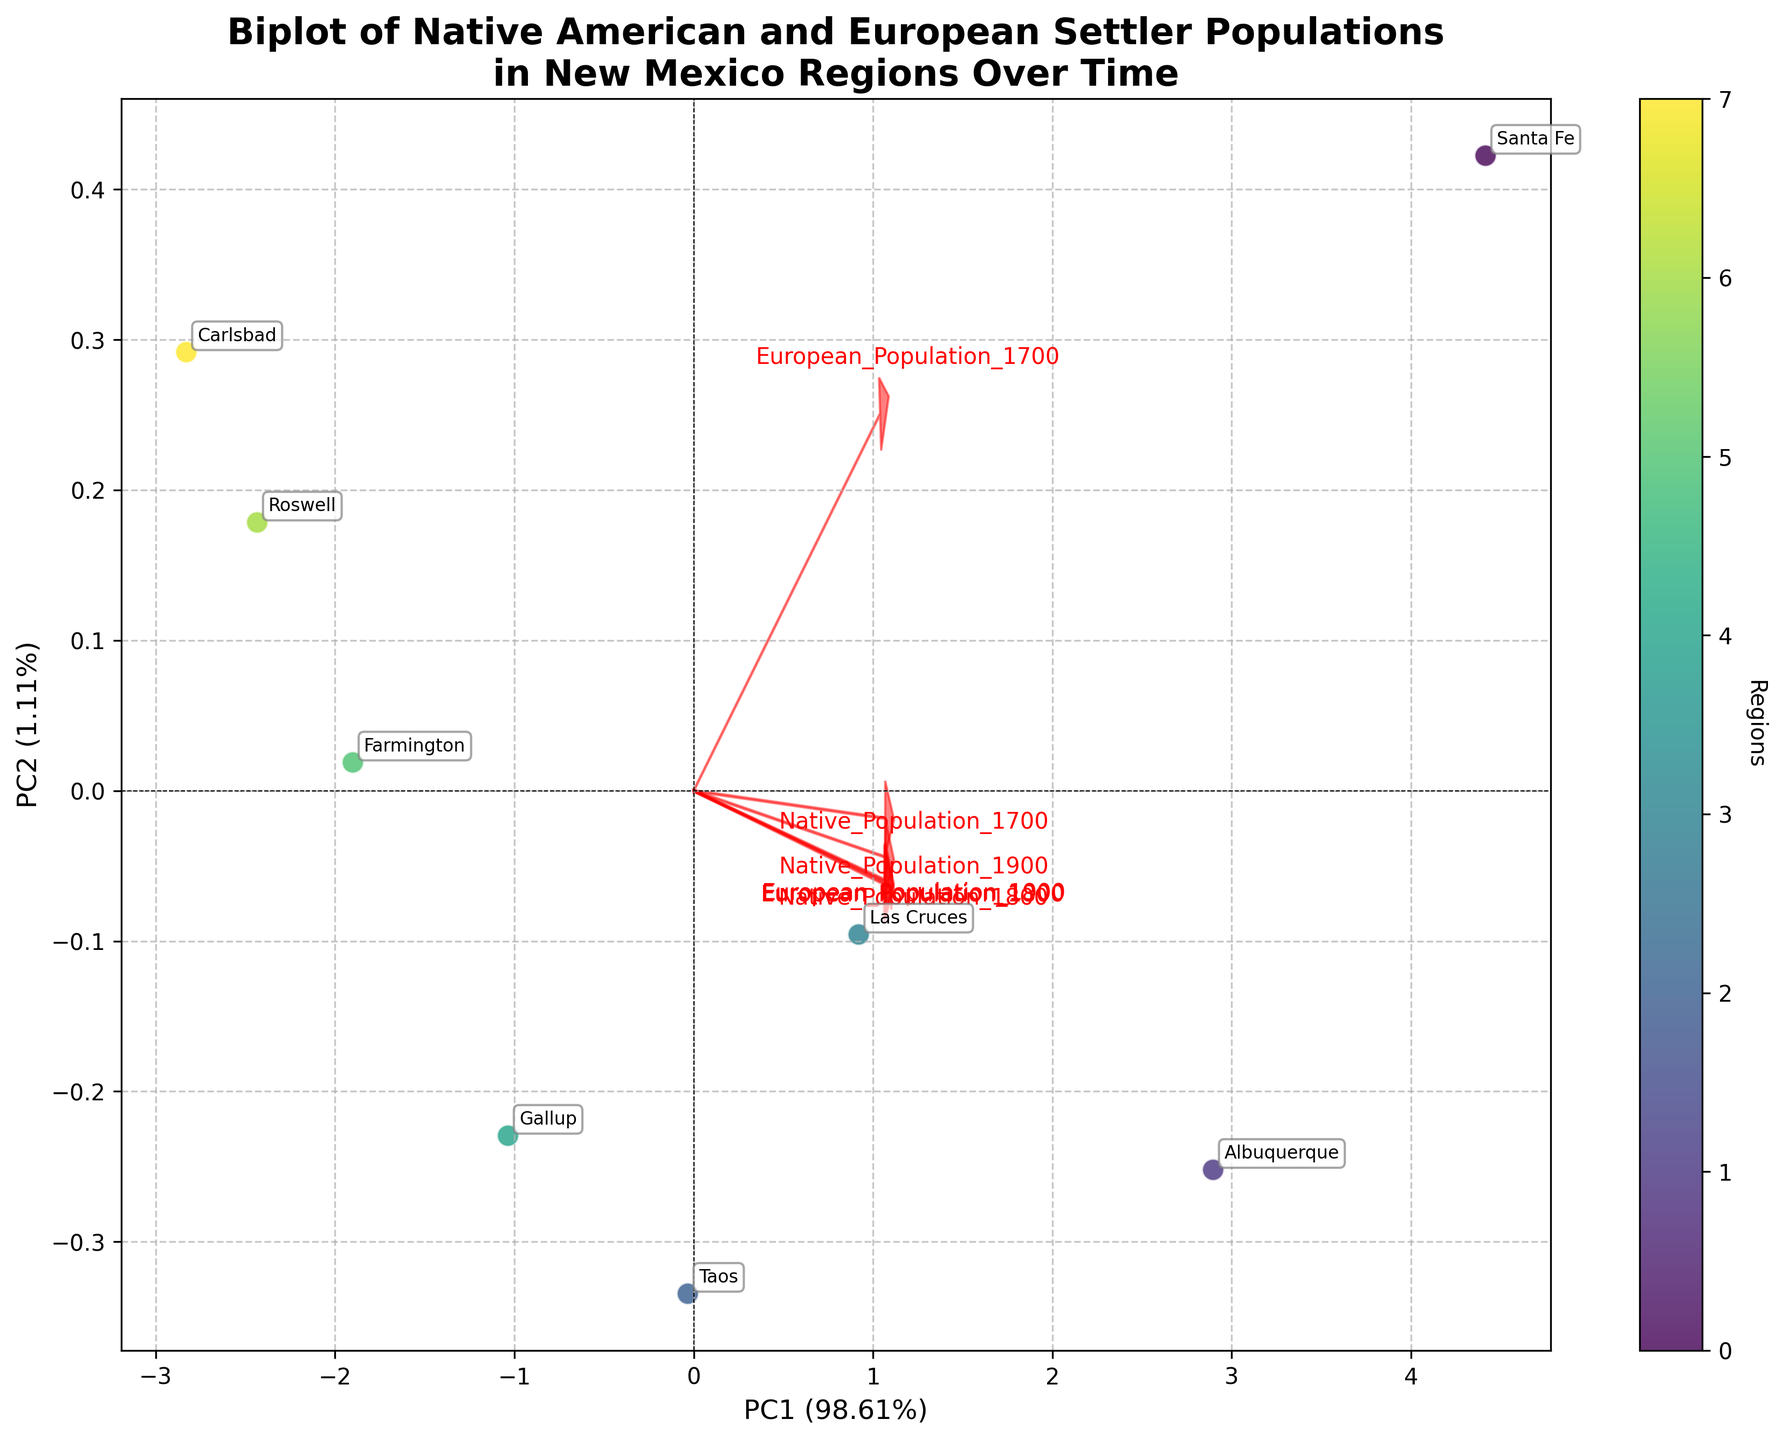What is the title of the biplot? The title is displayed at the top of the plot and reads "Biplot of Native American and European Settler Populations in New Mexico Regions Over Time".
Answer: Biplot of Native American and European Settler Populations in New Mexico Regions Over Time How many regions are represented in the biplot? Each data point in the scatter plot represents a region. By counting the labels, we see that there are 8 regions: Santa Fe, Albuquerque, Taos, Las Cruces, Gallup, Farmington, Roswell, and Carlsbad.
Answer: 8 What does the color of the data points represent? The color of the data points is indicated by the colorbar on the right side of the plot. Each region has a unique color representing its identifier.
Answer: Regions Which region corresponds to the data point closest to the origin (0,0)? By examining the scatter plot, the point closest to the origin, where the X and Y axes intersect, is annotated as Farmington.
Answer: Farmington Which population variable shows the strongest correlation with PC1 (Principal Component 1)? The arrow length and direction indicate the correlation strength with PC1. The longest arrow pointing towards PC1 corresponds to "European_Population_1900", showing the strongest correlation with PC1.
Answer: European_Population_1900 Compare the native populations of Santa Fe and Albuquerque in 1700. Which one is higher? By looking at the lengths of arrows and their annotations, we see that Santa Fe has a higher native population in 1700 compared to Albuquerque.
Answer: Santa Fe Which region exhibits the largest European settler population by 1900? The region furthest toward the direction of the arrow for "European_Population_1900" on the plot is Santa Fe, indicating it has the largest European settler population by 1900.
Answer: Santa Fe Identify the axis labels of PC1 and PC2 along with their variance percentages. The labels for PC1 and PC2 are found on the axes of the biplot. PC1 is labeled "PC1 (x%)" where x represents the percentage variance it explains. Similar for PC2, labeled "PC2 (y%)"
Answer: PC1 and PC2 with their variance percentages Which region has the smallest native population consistently from 1700 to 1900? The region can be identified by looking at the arrow annotations for native populations from 1700 to 1900, showing Carlsbad consistently having the smallest native population throughout the time periods.
Answer: Carlsbad What is the relationship between native and European populations over time? By examining the directions of the arrows for Native and European populations, one can observe how they shift over time. The trend generally shows a decrease in native populations whereas European populations increase, indicating an inverse relationship over time.
Answer: Inverse relationship over time 